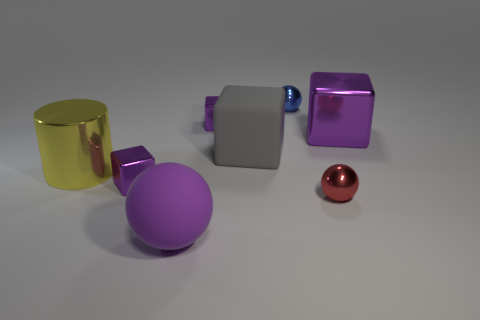Subtract all gray spheres. How many purple blocks are left? 3 Subtract 1 cubes. How many cubes are left? 3 Add 2 big gray cubes. How many objects exist? 10 Subtract all balls. How many objects are left? 5 Add 3 big purple matte balls. How many big purple matte balls are left? 4 Add 3 tiny metal balls. How many tiny metal balls exist? 5 Subtract 0 cyan spheres. How many objects are left? 8 Subtract all blue spheres. Subtract all gray things. How many objects are left? 6 